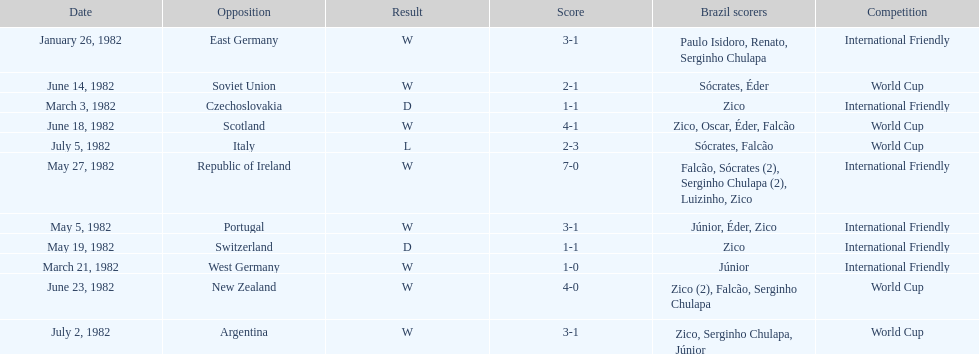Can you parse all the data within this table? {'header': ['Date', 'Opposition', 'Result', 'Score', 'Brazil scorers', 'Competition'], 'rows': [['January 26, 1982', 'East Germany', 'W', '3-1', 'Paulo Isidoro, Renato, Serginho Chulapa', 'International Friendly'], ['June 14, 1982', 'Soviet Union', 'W', '2-1', 'Sócrates, Éder', 'World Cup'], ['March 3, 1982', 'Czechoslovakia', 'D', '1-1', 'Zico', 'International Friendly'], ['June 18, 1982', 'Scotland', 'W', '4-1', 'Zico, Oscar, Éder, Falcão', 'World Cup'], ['July 5, 1982', 'Italy', 'L', '2-3', 'Sócrates, Falcão', 'World Cup'], ['May 27, 1982', 'Republic of Ireland', 'W', '7-0', 'Falcão, Sócrates (2), Serginho Chulapa (2), Luizinho, Zico', 'International Friendly'], ['May 5, 1982', 'Portugal', 'W', '3-1', 'Júnior, Éder, Zico', 'International Friendly'], ['May 19, 1982', 'Switzerland', 'D', '1-1', 'Zico', 'International Friendly'], ['March 21, 1982', 'West Germany', 'W', '1-0', 'Júnior', 'International Friendly'], ['June 23, 1982', 'New Zealand', 'W', '4-0', 'Zico (2), Falcão, Serginho Chulapa', 'World Cup'], ['July 2, 1982', 'Argentina', 'W', '3-1', 'Zico, Serginho Chulapa, Júnior', 'World Cup']]} What was the total number of losses brazil suffered? 1. 